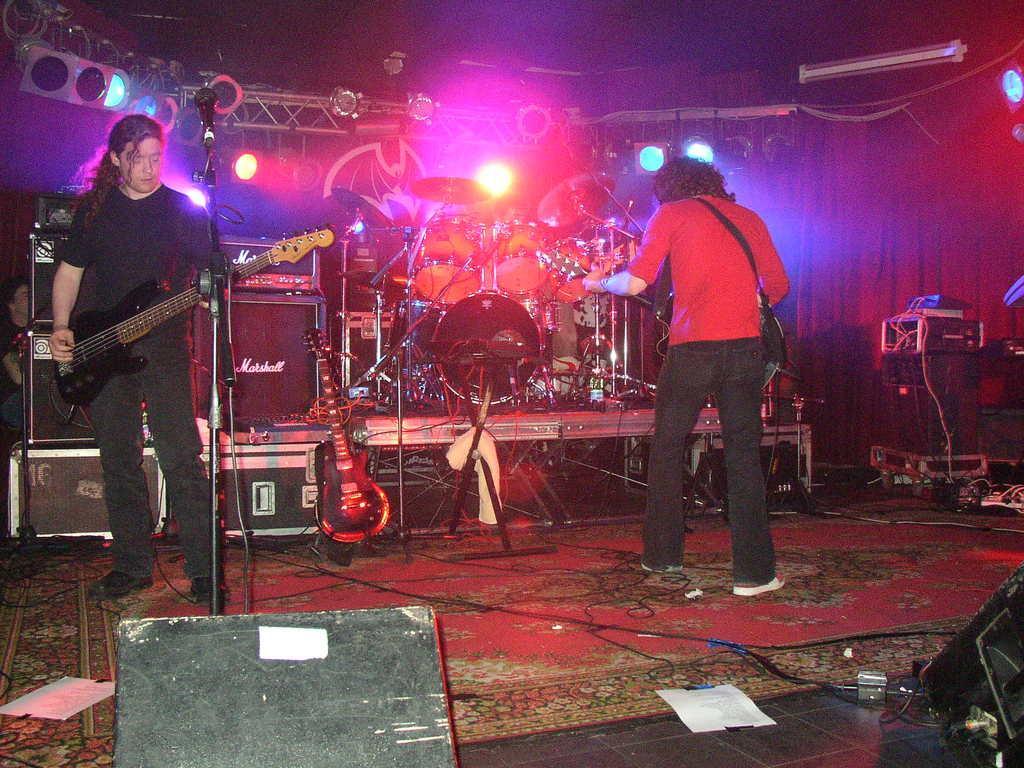Can you describe this image briefly? In the picture we can find two persons are standing, one person is holding a guitar near the microphone, another person is turning back and holding a guitar. In the background we can find orchestra, music items and colorful lights attached to the stand. The two persons are standing on the carpet. 